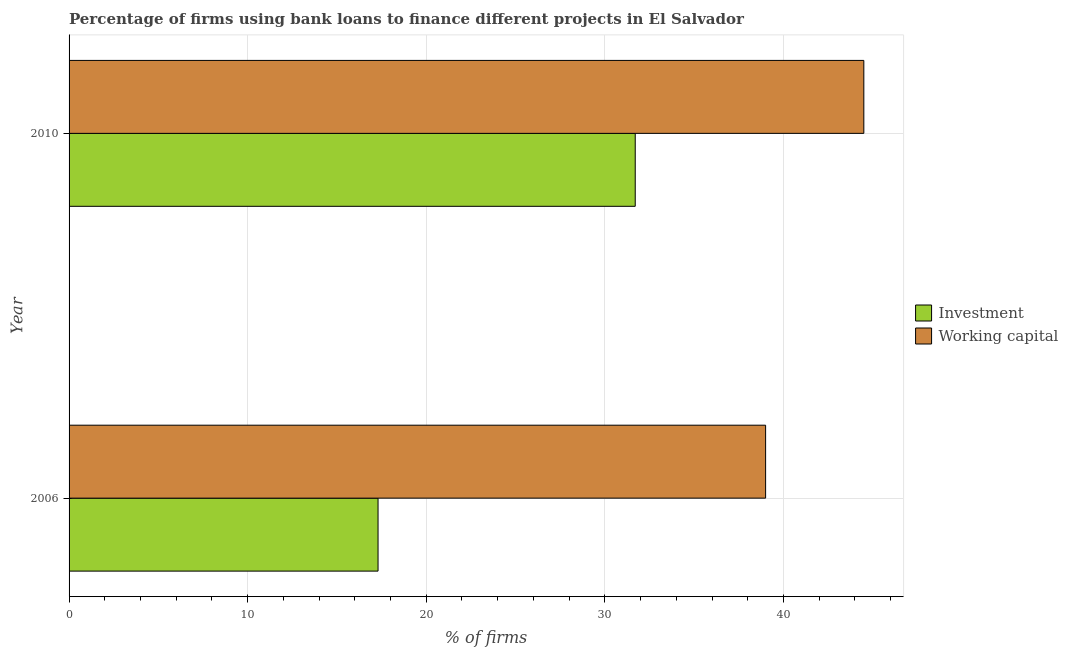How many different coloured bars are there?
Ensure brevity in your answer.  2. How many groups of bars are there?
Offer a very short reply. 2. Are the number of bars per tick equal to the number of legend labels?
Offer a terse response. Yes. Are the number of bars on each tick of the Y-axis equal?
Ensure brevity in your answer.  Yes. How many bars are there on the 2nd tick from the top?
Provide a short and direct response. 2. Across all years, what is the maximum percentage of firms using banks to finance investment?
Ensure brevity in your answer.  31.7. Across all years, what is the minimum percentage of firms using banks to finance working capital?
Ensure brevity in your answer.  39. What is the total percentage of firms using banks to finance investment in the graph?
Make the answer very short. 49. What is the difference between the percentage of firms using banks to finance investment in 2006 and that in 2010?
Your answer should be very brief. -14.4. What is the difference between the percentage of firms using banks to finance working capital in 2010 and the percentage of firms using banks to finance investment in 2006?
Your answer should be very brief. 27.2. What is the average percentage of firms using banks to finance investment per year?
Your answer should be very brief. 24.5. In how many years, is the percentage of firms using banks to finance investment greater than 10 %?
Your answer should be very brief. 2. What is the ratio of the percentage of firms using banks to finance working capital in 2006 to that in 2010?
Ensure brevity in your answer.  0.88. Is the percentage of firms using banks to finance working capital in 2006 less than that in 2010?
Offer a terse response. Yes. Is the difference between the percentage of firms using banks to finance investment in 2006 and 2010 greater than the difference between the percentage of firms using banks to finance working capital in 2006 and 2010?
Your response must be concise. No. In how many years, is the percentage of firms using banks to finance investment greater than the average percentage of firms using banks to finance investment taken over all years?
Ensure brevity in your answer.  1. What does the 1st bar from the top in 2006 represents?
Provide a succinct answer. Working capital. What does the 2nd bar from the bottom in 2010 represents?
Provide a succinct answer. Working capital. Are the values on the major ticks of X-axis written in scientific E-notation?
Ensure brevity in your answer.  No. How many legend labels are there?
Give a very brief answer. 2. What is the title of the graph?
Your response must be concise. Percentage of firms using bank loans to finance different projects in El Salvador. What is the label or title of the X-axis?
Provide a short and direct response. % of firms. What is the label or title of the Y-axis?
Provide a succinct answer. Year. What is the % of firms in Investment in 2010?
Offer a very short reply. 31.7. What is the % of firms of Working capital in 2010?
Your answer should be very brief. 44.5. Across all years, what is the maximum % of firms of Investment?
Offer a very short reply. 31.7. Across all years, what is the maximum % of firms of Working capital?
Provide a short and direct response. 44.5. Across all years, what is the minimum % of firms in Investment?
Ensure brevity in your answer.  17.3. What is the total % of firms in Investment in the graph?
Your answer should be compact. 49. What is the total % of firms of Working capital in the graph?
Your answer should be compact. 83.5. What is the difference between the % of firms of Investment in 2006 and that in 2010?
Your answer should be compact. -14.4. What is the difference between the % of firms of Working capital in 2006 and that in 2010?
Make the answer very short. -5.5. What is the difference between the % of firms of Investment in 2006 and the % of firms of Working capital in 2010?
Make the answer very short. -27.2. What is the average % of firms in Working capital per year?
Your answer should be compact. 41.75. In the year 2006, what is the difference between the % of firms of Investment and % of firms of Working capital?
Provide a short and direct response. -21.7. What is the ratio of the % of firms in Investment in 2006 to that in 2010?
Give a very brief answer. 0.55. What is the ratio of the % of firms of Working capital in 2006 to that in 2010?
Your answer should be very brief. 0.88. What is the difference between the highest and the lowest % of firms in Investment?
Make the answer very short. 14.4. 